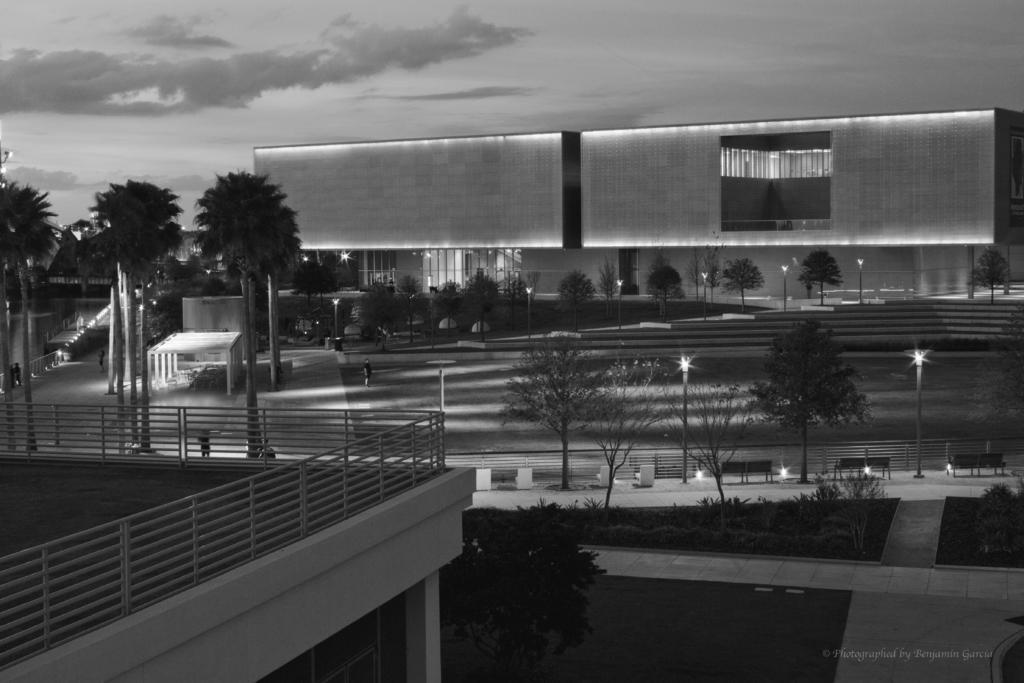Could you give a brief overview of what you see in this image? In the we can see a building with a railing and besides to it, we can see a tree to the path near to the path we can see some trees, plants and poles with a light and in the background we can also see a building and a sky with clouds. 